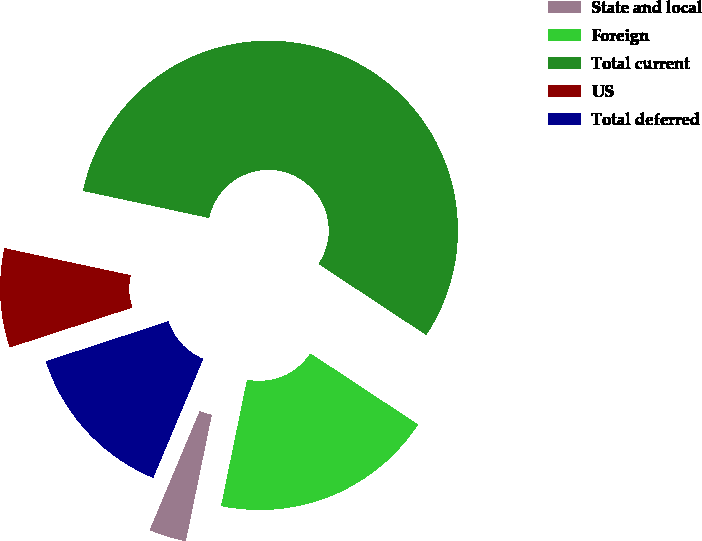Convert chart. <chart><loc_0><loc_0><loc_500><loc_500><pie_chart><fcel>State and local<fcel>Foreign<fcel>Total current<fcel>US<fcel>Total deferred<nl><fcel>3.1%<fcel>18.94%<fcel>55.92%<fcel>8.38%<fcel>13.66%<nl></chart> 